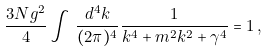<formula> <loc_0><loc_0><loc_500><loc_500>\frac { 3 N g ^ { 2 } } { 4 } \int \, \frac { d ^ { 4 } k } { ( 2 \pi ) ^ { 4 } } \frac { 1 } { k ^ { 4 } + m ^ { 2 } k ^ { 2 } + \gamma ^ { 4 } } = 1 \, ,</formula> 